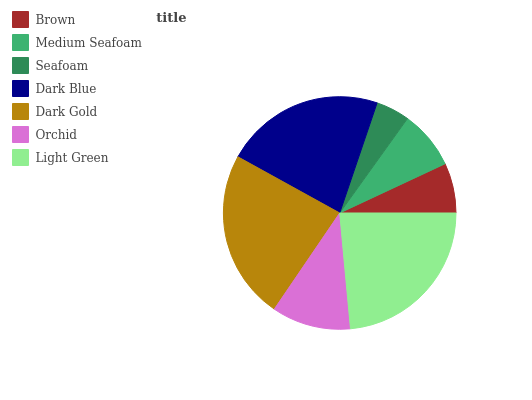Is Seafoam the minimum?
Answer yes or no. Yes. Is Light Green the maximum?
Answer yes or no. Yes. Is Medium Seafoam the minimum?
Answer yes or no. No. Is Medium Seafoam the maximum?
Answer yes or no. No. Is Medium Seafoam greater than Brown?
Answer yes or no. Yes. Is Brown less than Medium Seafoam?
Answer yes or no. Yes. Is Brown greater than Medium Seafoam?
Answer yes or no. No. Is Medium Seafoam less than Brown?
Answer yes or no. No. Is Orchid the high median?
Answer yes or no. Yes. Is Orchid the low median?
Answer yes or no. Yes. Is Light Green the high median?
Answer yes or no. No. Is Seafoam the low median?
Answer yes or no. No. 